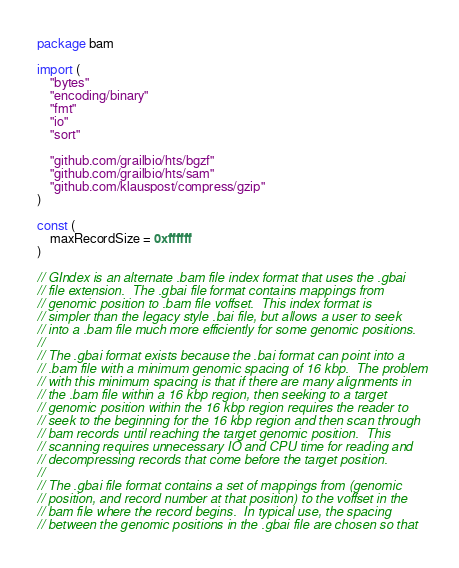Convert code to text. <code><loc_0><loc_0><loc_500><loc_500><_Go_>package bam

import (
	"bytes"
	"encoding/binary"
	"fmt"
	"io"
	"sort"

	"github.com/grailbio/hts/bgzf"
	"github.com/grailbio/hts/sam"
	"github.com/klauspost/compress/gzip"
)

const (
	maxRecordSize = 0xffffff
)

// GIndex is an alternate .bam file index format that uses the .gbai
// file extension.  The .gbai file format contains mappings from
// genomic position to .bam file voffset.  This index format is
// simpler than the legacy style .bai file, but allows a user to seek
// into a .bam file much more efficiently for some genomic positions.
//
// The .gbai format exists because the .bai format can point into a
// .bam file with a minimum genomic spacing of 16 kbp.  The problem
// with this minimum spacing is that if there are many alignments in
// the .bam file within a 16 kbp region, then seeking to a target
// genomic position within the 16 kbp region requires the reader to
// seek to the beginning for the 16 kbp region and then scan through
// bam records until reaching the target genomic position.  This
// scanning requires unnecessary IO and CPU time for reading and
// decompressing records that come before the target position.
//
// The .gbai file format contains a set of mappings from (genomic
// position, and record number at that position) to the voffset in the
// bam file where the record begins.  In typical use, the spacing
// between the genomic positions in the .gbai file are chosen so that</code> 